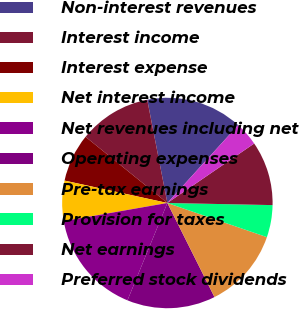Convert chart. <chart><loc_0><loc_0><loc_500><loc_500><pie_chart><fcel>Non-interest revenues<fcel>Interest income<fcel>Interest expense<fcel>Net interest income<fcel>Net revenues including net<fcel>Operating expenses<fcel>Pre-tax earnings<fcel>Provision for taxes<fcel>Net earnings<fcel>Preferred stock dividends<nl><fcel>14.81%<fcel>11.11%<fcel>7.41%<fcel>6.17%<fcel>16.05%<fcel>13.58%<fcel>12.35%<fcel>4.94%<fcel>9.88%<fcel>3.7%<nl></chart> 